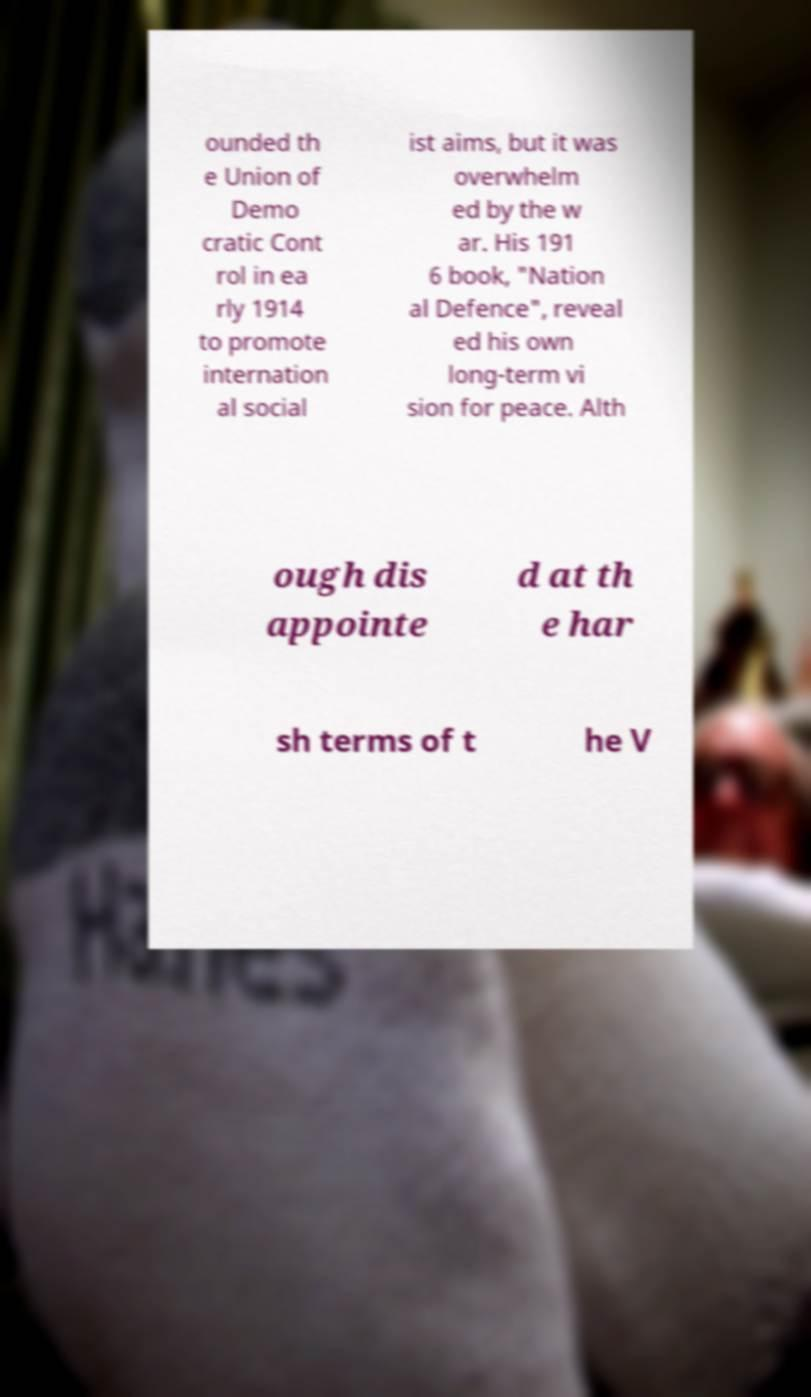Please identify and transcribe the text found in this image. ounded th e Union of Demo cratic Cont rol in ea rly 1914 to promote internation al social ist aims, but it was overwhelm ed by the w ar. His 191 6 book, "Nation al Defence", reveal ed his own long-term vi sion for peace. Alth ough dis appointe d at th e har sh terms of t he V 